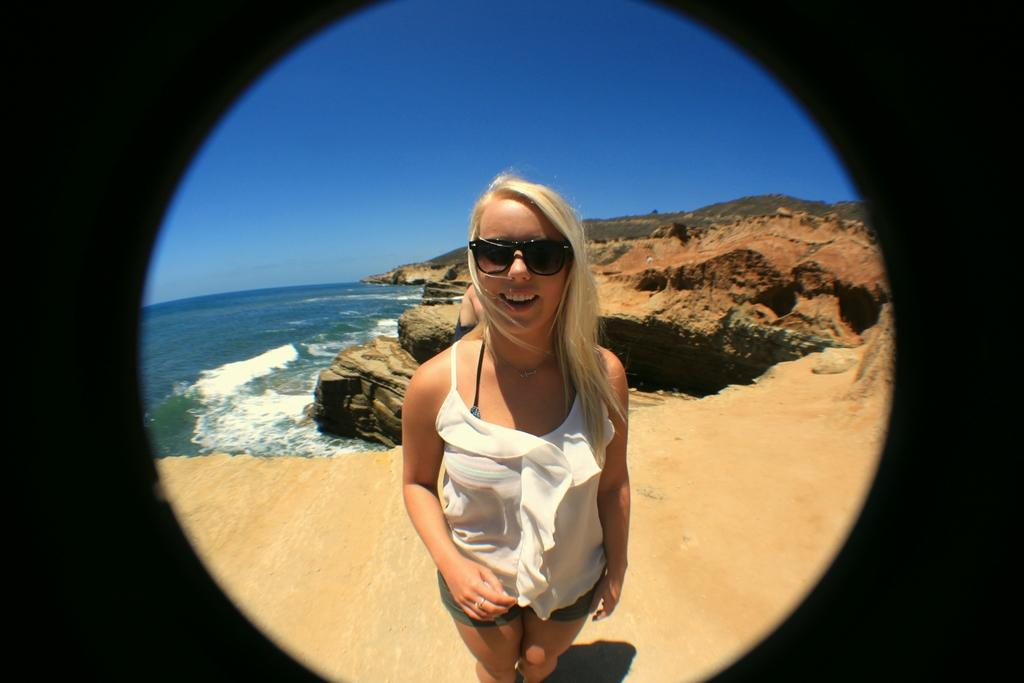Who is present in the image? There is a girl in the image. Where is the girl located? The girl is standing on the sea shore. What can be seen behind the girl? There is a big rock behind the girl. What type of natural environment is depicted in the image? The image includes a beach. How many chairs can be seen on the beach in the image? There are no chairs visible in the image; it only features a girl, a big rock, and the beach. What type of berry is growing on the big rock in the image? There are no berries present on the big rock or anywhere else in the image. 